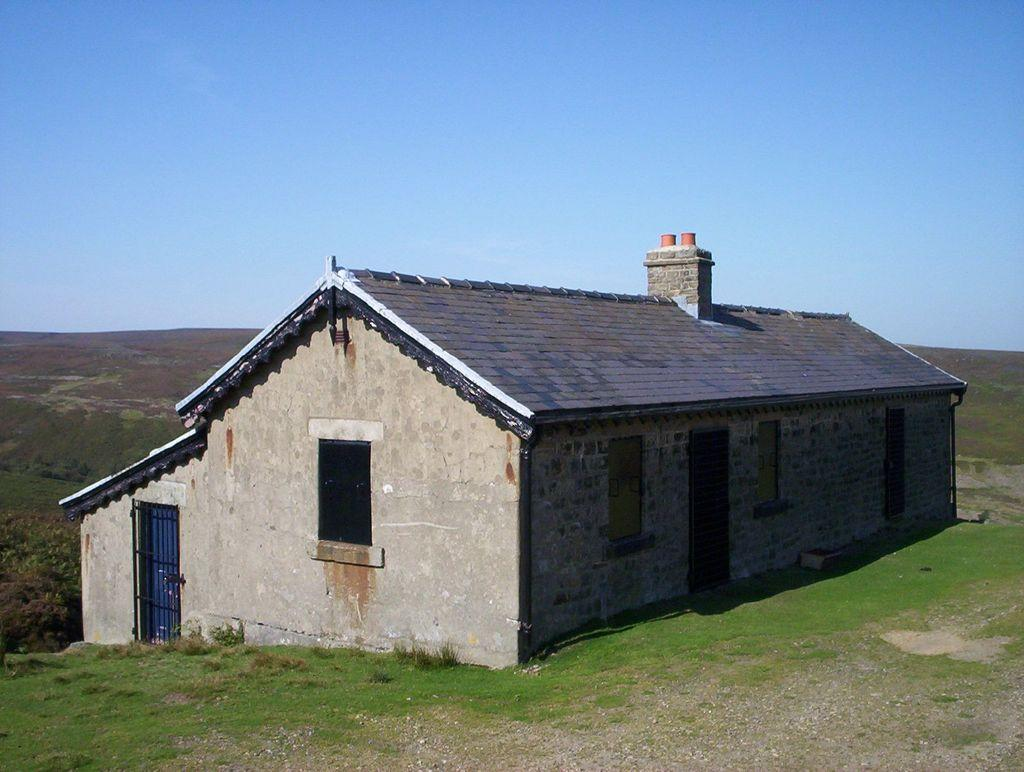What type of structure is in the picture? There is a house in the picture. What type of vegetation can be seen in the picture? There is grass visible in the picture. What part of the natural environment is visible in the picture? The sky is visible in the background of the picture. What type of wing can be seen on the house in the image? There is no wing present on the house in the image. What type of flag is flying near the house in the image? There is no flag present near the house in the image. 